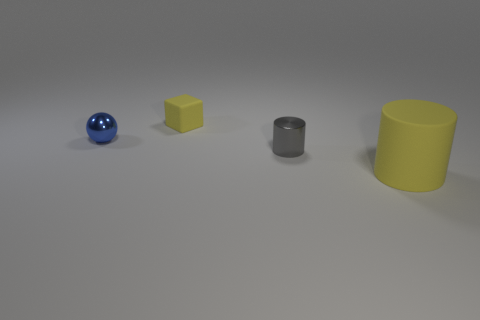Add 4 large red metal objects. How many objects exist? 8 Subtract all cubes. How many objects are left? 3 Add 1 big yellow cylinders. How many big yellow cylinders exist? 2 Subtract 1 yellow cylinders. How many objects are left? 3 Subtract all big spheres. Subtract all small matte things. How many objects are left? 3 Add 1 blue things. How many blue things are left? 2 